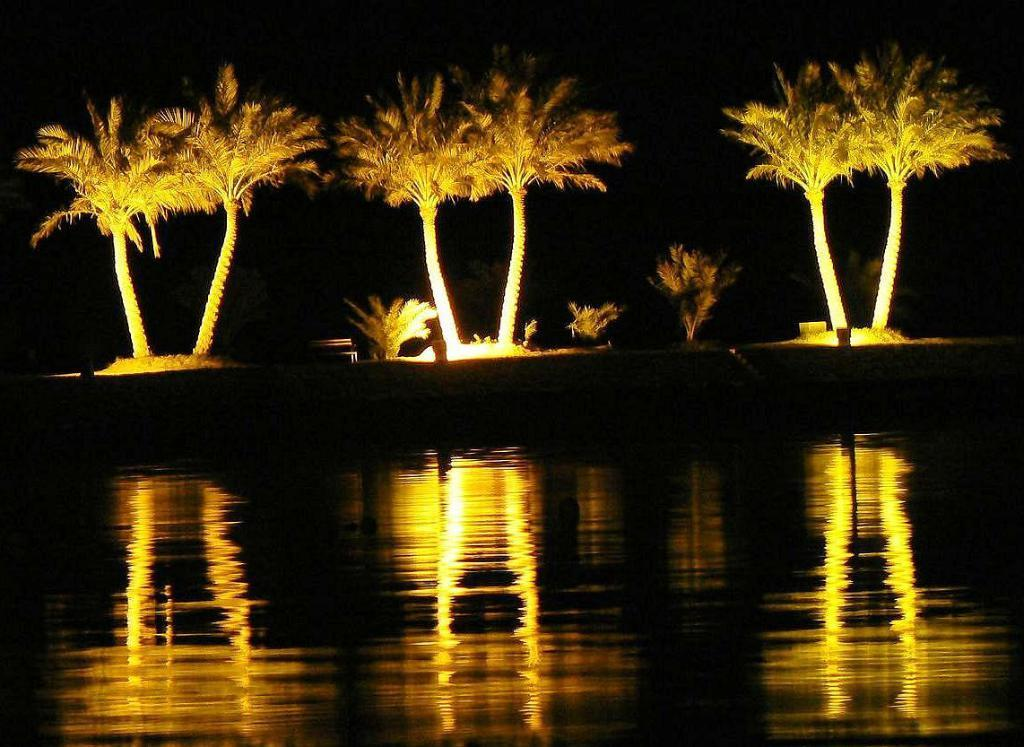What is located in the foreground of the image? There are trees and plants in the foreground of the image. What is the location of the trees and plants in relation to a body of water? The trees and plants are placed near a river. What is the lighting condition in the image? The image was taken in the dark. What type of attraction can be seen near the river in the image? There is no attraction visible in the image; it only features trees, plants, and a river. Are there any bears visible near the river in the image? There are no bears present in the image. 